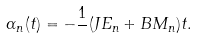<formula> <loc_0><loc_0><loc_500><loc_500>\alpha _ { n } ( t ) = - \frac { 1 } { } ( J E _ { n } + B M _ { n } ) t .</formula> 